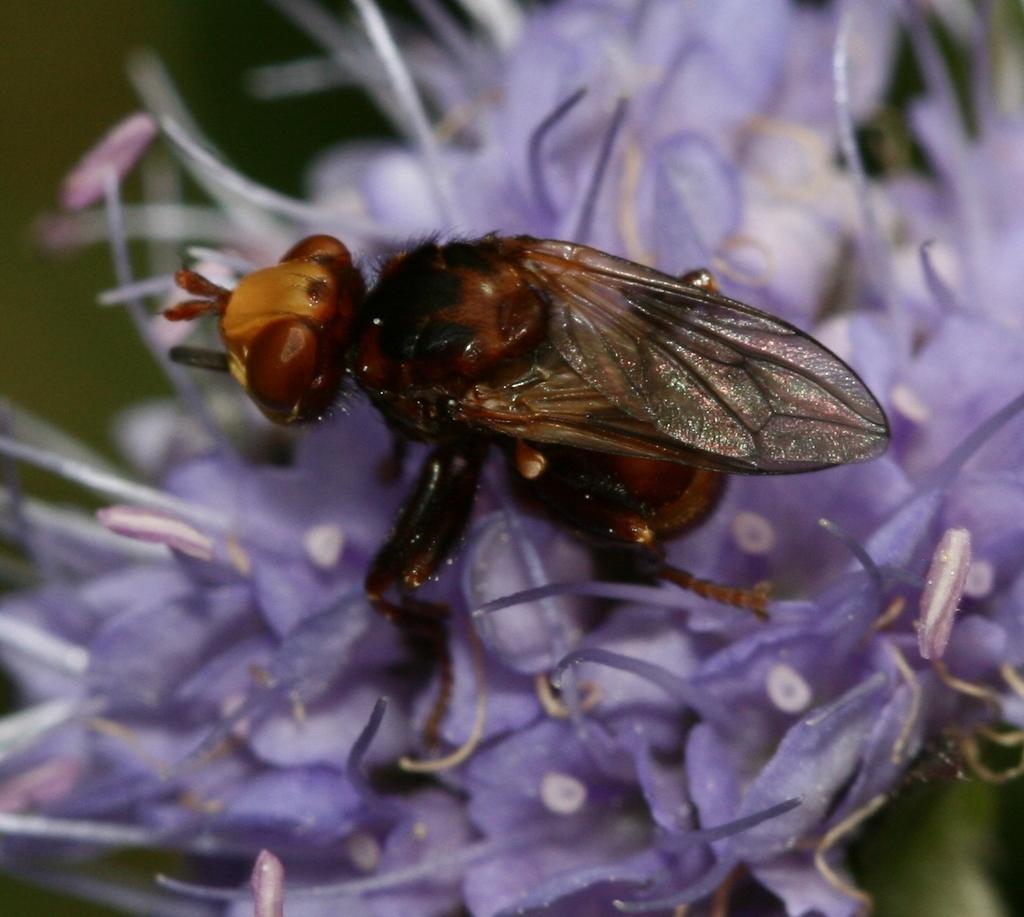Describe this image in one or two sentences. In the center of the image we can see one flower, which is in violet color. On the flower, we can see one insect, which is brown and black color. In the background, we can see it is blurred. 